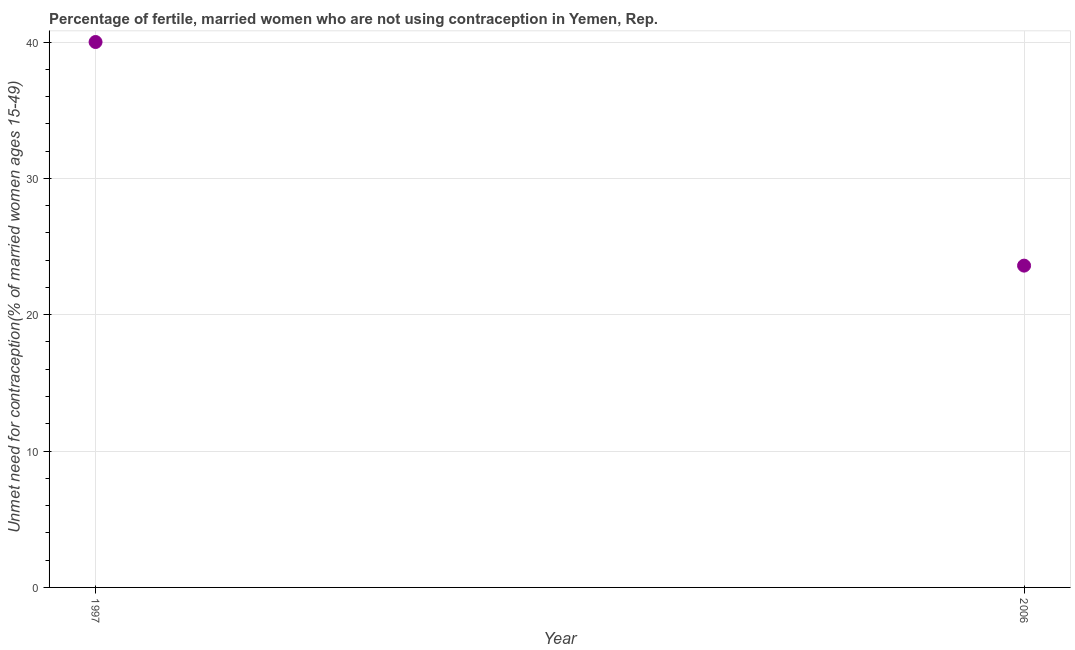What is the number of married women who are not using contraception in 1997?
Provide a short and direct response. 40. Across all years, what is the maximum number of married women who are not using contraception?
Offer a very short reply. 40. Across all years, what is the minimum number of married women who are not using contraception?
Your answer should be compact. 23.6. What is the sum of the number of married women who are not using contraception?
Ensure brevity in your answer.  63.6. What is the average number of married women who are not using contraception per year?
Give a very brief answer. 31.8. What is the median number of married women who are not using contraception?
Offer a very short reply. 31.8. In how many years, is the number of married women who are not using contraception greater than 38 %?
Provide a succinct answer. 1. Do a majority of the years between 1997 and 2006 (inclusive) have number of married women who are not using contraception greater than 36 %?
Keep it short and to the point. No. What is the ratio of the number of married women who are not using contraception in 1997 to that in 2006?
Your answer should be very brief. 1.69. How many years are there in the graph?
Provide a succinct answer. 2. What is the difference between two consecutive major ticks on the Y-axis?
Your answer should be compact. 10. Are the values on the major ticks of Y-axis written in scientific E-notation?
Offer a terse response. No. What is the title of the graph?
Ensure brevity in your answer.  Percentage of fertile, married women who are not using contraception in Yemen, Rep. What is the label or title of the X-axis?
Give a very brief answer. Year. What is the label or title of the Y-axis?
Make the answer very short.  Unmet need for contraception(% of married women ages 15-49). What is the  Unmet need for contraception(% of married women ages 15-49) in 1997?
Keep it short and to the point. 40. What is the  Unmet need for contraception(% of married women ages 15-49) in 2006?
Keep it short and to the point. 23.6. What is the difference between the  Unmet need for contraception(% of married women ages 15-49) in 1997 and 2006?
Your answer should be very brief. 16.4. What is the ratio of the  Unmet need for contraception(% of married women ages 15-49) in 1997 to that in 2006?
Give a very brief answer. 1.7. 